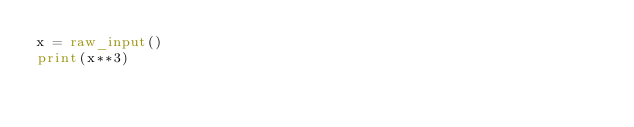<code> <loc_0><loc_0><loc_500><loc_500><_Python_>x = raw_input()
print(x**3)</code> 